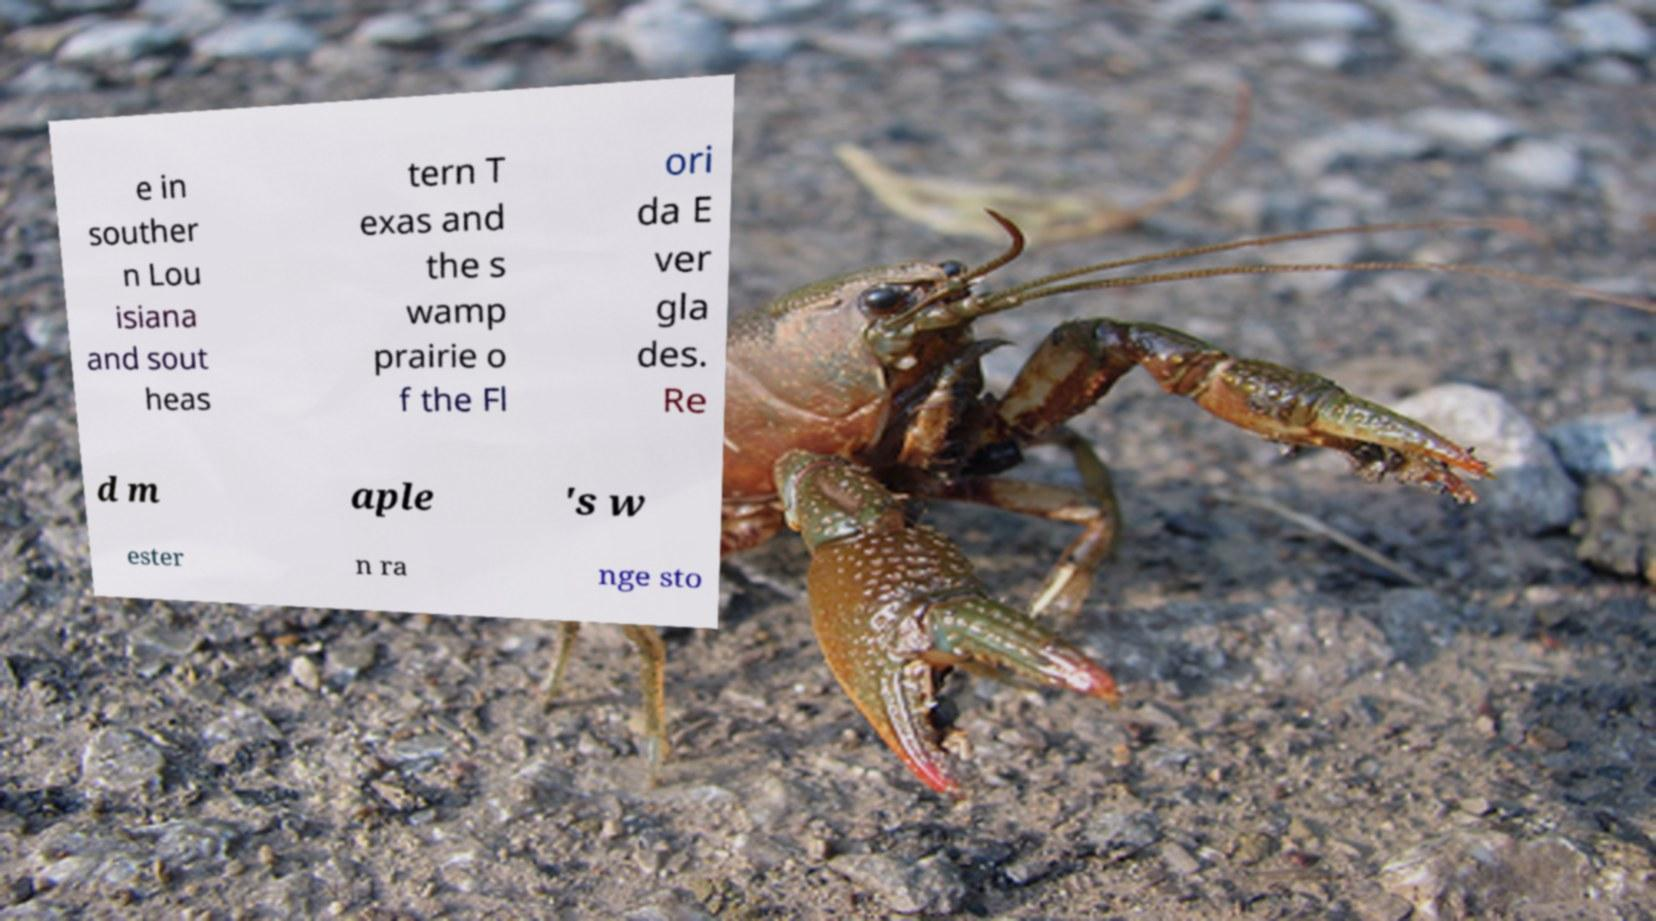I need the written content from this picture converted into text. Can you do that? e in souther n Lou isiana and sout heas tern T exas and the s wamp prairie o f the Fl ori da E ver gla des. Re d m aple 's w ester n ra nge sto 